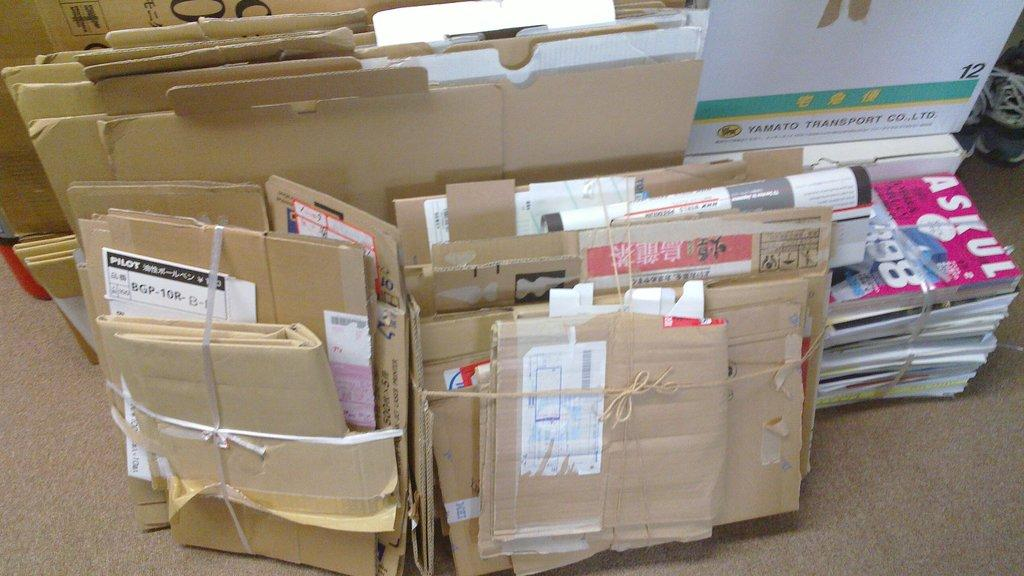Provide a one-sentence caption for the provided image. An Askul magazine is on top of a pile of mail. 